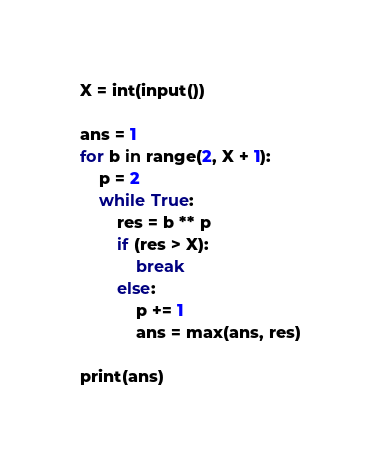<code> <loc_0><loc_0><loc_500><loc_500><_Python_>X = int(input())

ans = 1
for b in range(2, X + 1):
    p = 2
    while True:
        res = b ** p
        if (res > X):
            break
        else:
            p += 1
            ans = max(ans, res)

print(ans)
</code> 